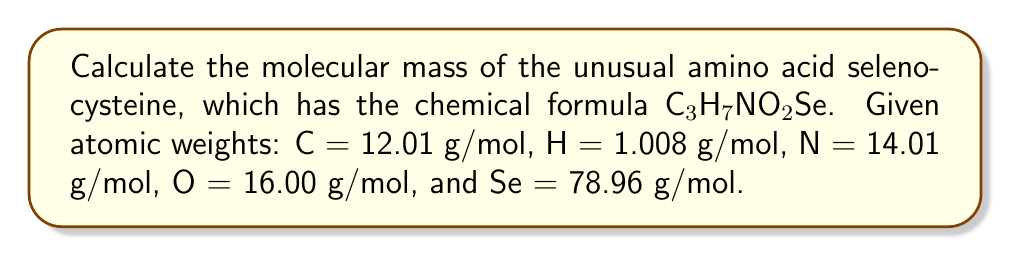Can you solve this math problem? To calculate the molecular mass of selenocysteine, we need to sum the masses of all atoms in the molecule:

1. Carbon (C): 3 atoms
   $3 \times 12.01 = 36.03$ g/mol

2. Hydrogen (H): 7 atoms
   $7 \times 1.008 = 7.056$ g/mol

3. Nitrogen (N): 1 atom
   $1 \times 14.01 = 14.01$ g/mol

4. Oxygen (O): 2 atoms
   $2 \times 16.00 = 32.00$ g/mol

5. Selenium (Se): 1 atom
   $1 \times 78.96 = 78.96$ g/mol

Sum all the masses:
$$36.03 + 7.056 + 14.01 + 32.00 + 78.96 = 168.056$$ g/mol

Therefore, the molecular mass of selenocysteine is 168.056 g/mol.
Answer: 168.056 g/mol 